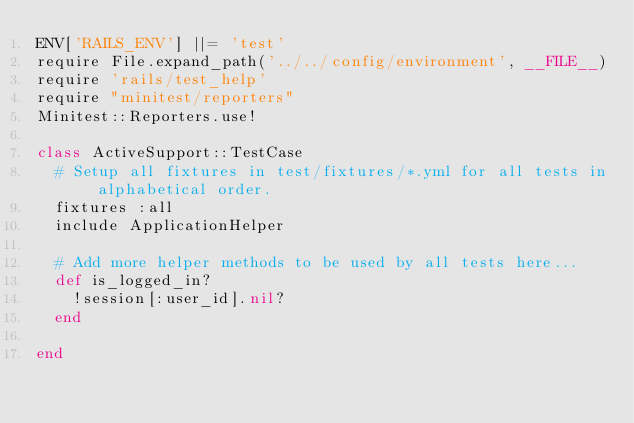Convert code to text. <code><loc_0><loc_0><loc_500><loc_500><_Ruby_>ENV['RAILS_ENV'] ||= 'test'
require File.expand_path('../../config/environment', __FILE__)
require 'rails/test_help'
require "minitest/reporters"
Minitest::Reporters.use!

class ActiveSupport::TestCase
  # Setup all fixtures in test/fixtures/*.yml for all tests in alphabetical order.
  fixtures :all
  include ApplicationHelper

  # Add more helper methods to be used by all tests here...
  def is_logged_in?
    !session[:user_id].nil?
  end
  
end
</code> 